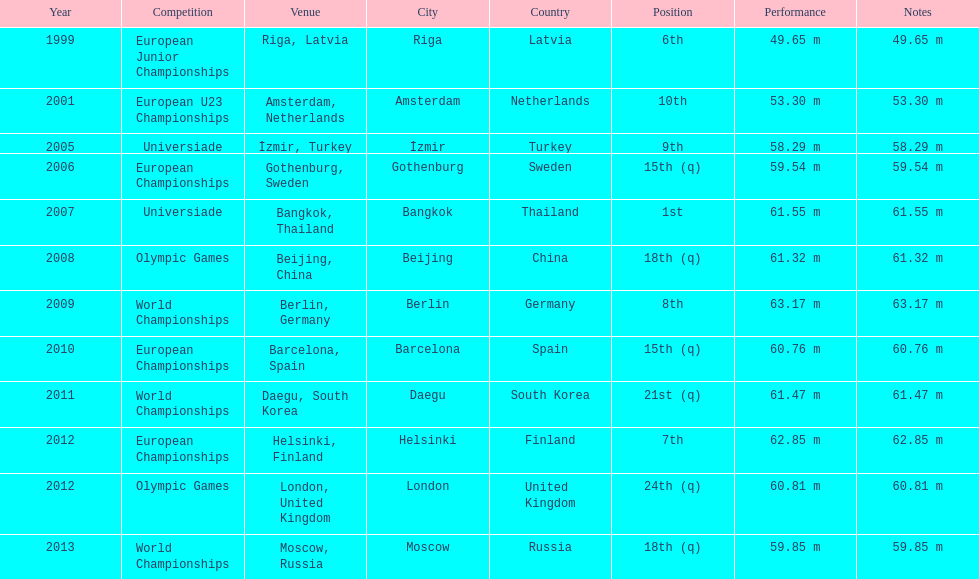How what listed year was a distance of only 53.30m reached? 2001. 